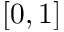<formula> <loc_0><loc_0><loc_500><loc_500>[ 0 , 1 ]</formula> 